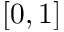<formula> <loc_0><loc_0><loc_500><loc_500>[ 0 , 1 ]</formula> 